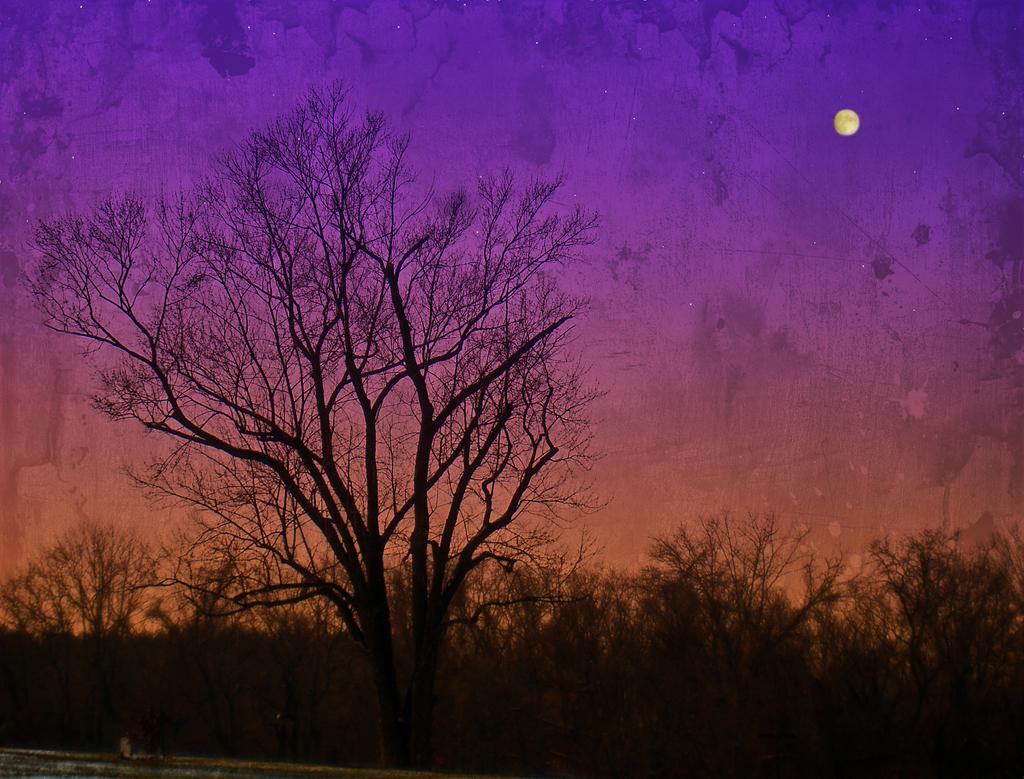What type of trees are in the image? There are dry trees in the image. What celestial body can be seen in the sky? The moon is visible in the sky. What type of jewel is hanging from the tree in the image? There is no jewel hanging from the tree in the image; it only features dry trees. Can you see a fire hydrant in the image? There is no fire hydrant present in the image. 